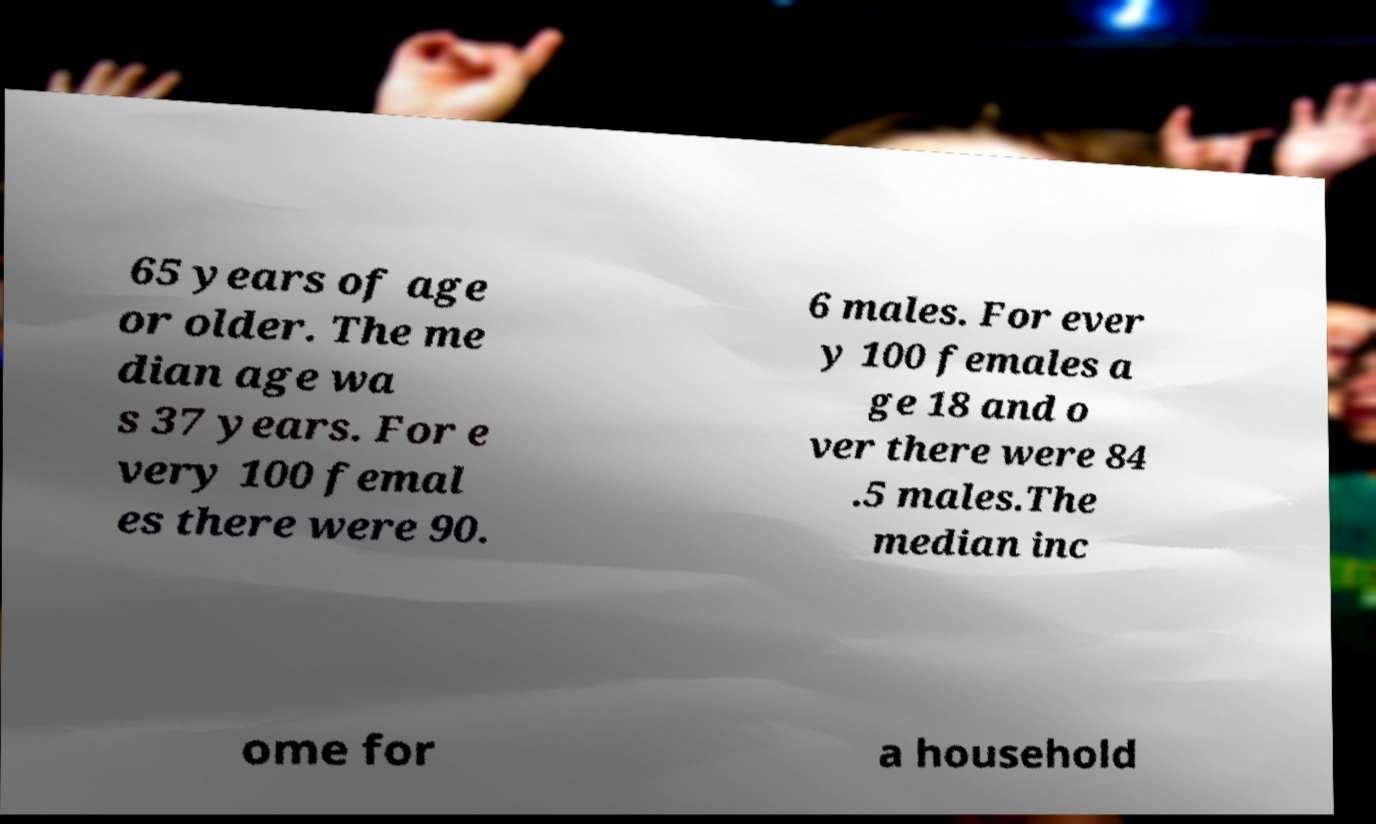Could you extract and type out the text from this image? 65 years of age or older. The me dian age wa s 37 years. For e very 100 femal es there were 90. 6 males. For ever y 100 females a ge 18 and o ver there were 84 .5 males.The median inc ome for a household 